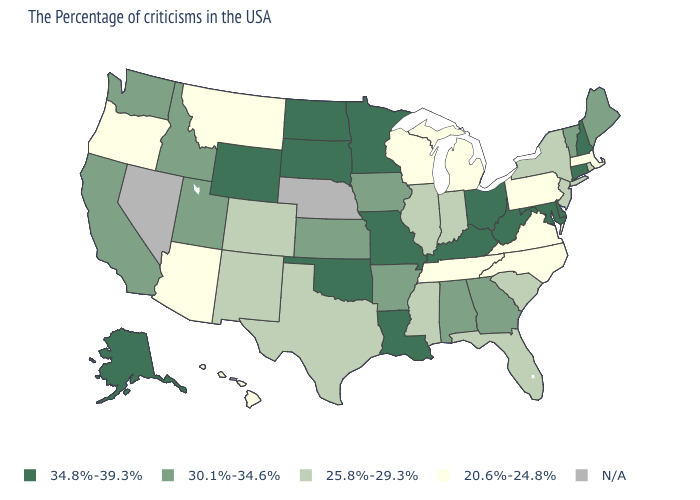What is the value of Alabama?
Write a very short answer. 30.1%-34.6%. What is the value of North Carolina?
Write a very short answer. 20.6%-24.8%. What is the value of New Hampshire?
Write a very short answer. 34.8%-39.3%. Which states have the highest value in the USA?
Concise answer only. New Hampshire, Connecticut, Delaware, Maryland, West Virginia, Ohio, Kentucky, Louisiana, Missouri, Minnesota, Oklahoma, South Dakota, North Dakota, Wyoming, Alaska. What is the value of New Hampshire?
Answer briefly. 34.8%-39.3%. Does Maine have the lowest value in the Northeast?
Give a very brief answer. No. Name the states that have a value in the range 25.8%-29.3%?
Be succinct. Rhode Island, New York, New Jersey, South Carolina, Florida, Indiana, Illinois, Mississippi, Texas, Colorado, New Mexico. Name the states that have a value in the range 30.1%-34.6%?
Answer briefly. Maine, Vermont, Georgia, Alabama, Arkansas, Iowa, Kansas, Utah, Idaho, California, Washington. What is the highest value in the South ?
Answer briefly. 34.8%-39.3%. Does the first symbol in the legend represent the smallest category?
Concise answer only. No. Among the states that border Minnesota , does North Dakota have the highest value?
Write a very short answer. Yes. What is the lowest value in states that border Massachusetts?
Answer briefly. 25.8%-29.3%. Does Colorado have the lowest value in the West?
Be succinct. No. Does South Dakota have the highest value in the USA?
Give a very brief answer. Yes. Name the states that have a value in the range 34.8%-39.3%?
Write a very short answer. New Hampshire, Connecticut, Delaware, Maryland, West Virginia, Ohio, Kentucky, Louisiana, Missouri, Minnesota, Oklahoma, South Dakota, North Dakota, Wyoming, Alaska. 